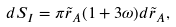<formula> <loc_0><loc_0><loc_500><loc_500>d S _ { I } = \pi \tilde { r } _ { A } ( 1 + 3 \omega ) d \tilde { r } _ { A } ,</formula> 